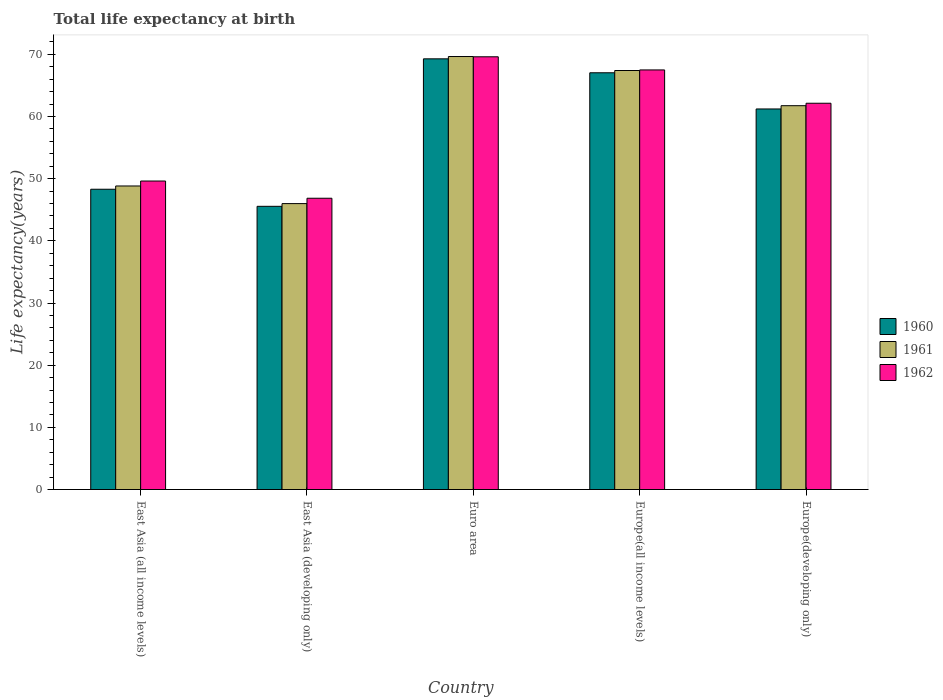How many different coloured bars are there?
Your response must be concise. 3. Are the number of bars on each tick of the X-axis equal?
Keep it short and to the point. Yes. How many bars are there on the 1st tick from the left?
Ensure brevity in your answer.  3. What is the label of the 4th group of bars from the left?
Make the answer very short. Europe(all income levels). What is the life expectancy at birth in in 1960 in Europe(all income levels)?
Your response must be concise. 67.03. Across all countries, what is the maximum life expectancy at birth in in 1960?
Offer a terse response. 69.27. Across all countries, what is the minimum life expectancy at birth in in 1961?
Offer a terse response. 45.99. In which country was the life expectancy at birth in in 1962 minimum?
Your response must be concise. East Asia (developing only). What is the total life expectancy at birth in in 1960 in the graph?
Your response must be concise. 291.36. What is the difference between the life expectancy at birth in in 1961 in East Asia (all income levels) and that in East Asia (developing only)?
Your response must be concise. 2.84. What is the difference between the life expectancy at birth in in 1960 in East Asia (developing only) and the life expectancy at birth in in 1962 in East Asia (all income levels)?
Your response must be concise. -4.07. What is the average life expectancy at birth in in 1962 per country?
Keep it short and to the point. 59.14. What is the difference between the life expectancy at birth in of/in 1962 and life expectancy at birth in of/in 1960 in East Asia (all income levels)?
Make the answer very short. 1.32. In how many countries, is the life expectancy at birth in in 1961 greater than 22 years?
Your answer should be very brief. 5. What is the ratio of the life expectancy at birth in in 1962 in Euro area to that in Europe(developing only)?
Keep it short and to the point. 1.12. Is the difference between the life expectancy at birth in in 1962 in Euro area and Europe(developing only) greater than the difference between the life expectancy at birth in in 1960 in Euro area and Europe(developing only)?
Offer a very short reply. No. What is the difference between the highest and the second highest life expectancy at birth in in 1962?
Give a very brief answer. -2.11. What is the difference between the highest and the lowest life expectancy at birth in in 1960?
Keep it short and to the point. 23.72. What does the 3rd bar from the right in East Asia (all income levels) represents?
Make the answer very short. 1960. Is it the case that in every country, the sum of the life expectancy at birth in in 1960 and life expectancy at birth in in 1962 is greater than the life expectancy at birth in in 1961?
Your answer should be compact. Yes. How many bars are there?
Provide a short and direct response. 15. Are all the bars in the graph horizontal?
Ensure brevity in your answer.  No. Does the graph contain any zero values?
Offer a terse response. No. How many legend labels are there?
Your response must be concise. 3. What is the title of the graph?
Keep it short and to the point. Total life expectancy at birth. What is the label or title of the Y-axis?
Provide a succinct answer. Life expectancy(years). What is the Life expectancy(years) in 1960 in East Asia (all income levels)?
Your answer should be compact. 48.3. What is the Life expectancy(years) of 1961 in East Asia (all income levels)?
Your answer should be very brief. 48.82. What is the Life expectancy(years) in 1962 in East Asia (all income levels)?
Give a very brief answer. 49.62. What is the Life expectancy(years) in 1960 in East Asia (developing only)?
Your response must be concise. 45.55. What is the Life expectancy(years) of 1961 in East Asia (developing only)?
Ensure brevity in your answer.  45.99. What is the Life expectancy(years) of 1962 in East Asia (developing only)?
Offer a terse response. 46.85. What is the Life expectancy(years) in 1960 in Euro area?
Your response must be concise. 69.27. What is the Life expectancy(years) in 1961 in Euro area?
Offer a very short reply. 69.64. What is the Life expectancy(years) in 1962 in Euro area?
Your answer should be very brief. 69.6. What is the Life expectancy(years) in 1960 in Europe(all income levels)?
Your answer should be compact. 67.03. What is the Life expectancy(years) of 1961 in Europe(all income levels)?
Your answer should be compact. 67.39. What is the Life expectancy(years) of 1962 in Europe(all income levels)?
Keep it short and to the point. 67.49. What is the Life expectancy(years) of 1960 in Europe(developing only)?
Provide a short and direct response. 61.21. What is the Life expectancy(years) of 1961 in Europe(developing only)?
Your answer should be very brief. 61.74. What is the Life expectancy(years) of 1962 in Europe(developing only)?
Your answer should be very brief. 62.13. Across all countries, what is the maximum Life expectancy(years) of 1960?
Provide a succinct answer. 69.27. Across all countries, what is the maximum Life expectancy(years) in 1961?
Offer a terse response. 69.64. Across all countries, what is the maximum Life expectancy(years) of 1962?
Make the answer very short. 69.6. Across all countries, what is the minimum Life expectancy(years) of 1960?
Offer a terse response. 45.55. Across all countries, what is the minimum Life expectancy(years) in 1961?
Make the answer very short. 45.99. Across all countries, what is the minimum Life expectancy(years) of 1962?
Offer a very short reply. 46.85. What is the total Life expectancy(years) of 1960 in the graph?
Make the answer very short. 291.36. What is the total Life expectancy(years) of 1961 in the graph?
Offer a terse response. 293.59. What is the total Life expectancy(years) in 1962 in the graph?
Provide a short and direct response. 295.69. What is the difference between the Life expectancy(years) in 1960 in East Asia (all income levels) and that in East Asia (developing only)?
Offer a very short reply. 2.75. What is the difference between the Life expectancy(years) of 1961 in East Asia (all income levels) and that in East Asia (developing only)?
Provide a succinct answer. 2.84. What is the difference between the Life expectancy(years) of 1962 in East Asia (all income levels) and that in East Asia (developing only)?
Make the answer very short. 2.77. What is the difference between the Life expectancy(years) in 1960 in East Asia (all income levels) and that in Euro area?
Keep it short and to the point. -20.98. What is the difference between the Life expectancy(years) of 1961 in East Asia (all income levels) and that in Euro area?
Keep it short and to the point. -20.82. What is the difference between the Life expectancy(years) in 1962 in East Asia (all income levels) and that in Euro area?
Provide a succinct answer. -19.98. What is the difference between the Life expectancy(years) in 1960 in East Asia (all income levels) and that in Europe(all income levels)?
Give a very brief answer. -18.73. What is the difference between the Life expectancy(years) of 1961 in East Asia (all income levels) and that in Europe(all income levels)?
Provide a succinct answer. -18.57. What is the difference between the Life expectancy(years) in 1962 in East Asia (all income levels) and that in Europe(all income levels)?
Your answer should be very brief. -17.87. What is the difference between the Life expectancy(years) in 1960 in East Asia (all income levels) and that in Europe(developing only)?
Ensure brevity in your answer.  -12.91. What is the difference between the Life expectancy(years) in 1961 in East Asia (all income levels) and that in Europe(developing only)?
Offer a terse response. -12.91. What is the difference between the Life expectancy(years) in 1962 in East Asia (all income levels) and that in Europe(developing only)?
Your response must be concise. -12.51. What is the difference between the Life expectancy(years) of 1960 in East Asia (developing only) and that in Euro area?
Provide a short and direct response. -23.72. What is the difference between the Life expectancy(years) of 1961 in East Asia (developing only) and that in Euro area?
Ensure brevity in your answer.  -23.66. What is the difference between the Life expectancy(years) of 1962 in East Asia (developing only) and that in Euro area?
Make the answer very short. -22.75. What is the difference between the Life expectancy(years) of 1960 in East Asia (developing only) and that in Europe(all income levels)?
Make the answer very short. -21.48. What is the difference between the Life expectancy(years) of 1961 in East Asia (developing only) and that in Europe(all income levels)?
Offer a terse response. -21.41. What is the difference between the Life expectancy(years) of 1962 in East Asia (developing only) and that in Europe(all income levels)?
Your response must be concise. -20.64. What is the difference between the Life expectancy(years) of 1960 in East Asia (developing only) and that in Europe(developing only)?
Your answer should be very brief. -15.66. What is the difference between the Life expectancy(years) of 1961 in East Asia (developing only) and that in Europe(developing only)?
Your answer should be compact. -15.75. What is the difference between the Life expectancy(years) of 1962 in East Asia (developing only) and that in Europe(developing only)?
Provide a short and direct response. -15.28. What is the difference between the Life expectancy(years) in 1960 in Euro area and that in Europe(all income levels)?
Provide a short and direct response. 2.24. What is the difference between the Life expectancy(years) in 1961 in Euro area and that in Europe(all income levels)?
Offer a terse response. 2.25. What is the difference between the Life expectancy(years) in 1962 in Euro area and that in Europe(all income levels)?
Your answer should be compact. 2.11. What is the difference between the Life expectancy(years) of 1960 in Euro area and that in Europe(developing only)?
Provide a succinct answer. 8.06. What is the difference between the Life expectancy(years) of 1961 in Euro area and that in Europe(developing only)?
Provide a succinct answer. 7.91. What is the difference between the Life expectancy(years) in 1962 in Euro area and that in Europe(developing only)?
Offer a very short reply. 7.47. What is the difference between the Life expectancy(years) of 1960 in Europe(all income levels) and that in Europe(developing only)?
Offer a very short reply. 5.82. What is the difference between the Life expectancy(years) in 1961 in Europe(all income levels) and that in Europe(developing only)?
Offer a very short reply. 5.66. What is the difference between the Life expectancy(years) in 1962 in Europe(all income levels) and that in Europe(developing only)?
Your answer should be compact. 5.36. What is the difference between the Life expectancy(years) in 1960 in East Asia (all income levels) and the Life expectancy(years) in 1961 in East Asia (developing only)?
Your answer should be very brief. 2.31. What is the difference between the Life expectancy(years) in 1960 in East Asia (all income levels) and the Life expectancy(years) in 1962 in East Asia (developing only)?
Your answer should be compact. 1.45. What is the difference between the Life expectancy(years) in 1961 in East Asia (all income levels) and the Life expectancy(years) in 1962 in East Asia (developing only)?
Your response must be concise. 1.97. What is the difference between the Life expectancy(years) of 1960 in East Asia (all income levels) and the Life expectancy(years) of 1961 in Euro area?
Make the answer very short. -21.35. What is the difference between the Life expectancy(years) in 1960 in East Asia (all income levels) and the Life expectancy(years) in 1962 in Euro area?
Ensure brevity in your answer.  -21.3. What is the difference between the Life expectancy(years) in 1961 in East Asia (all income levels) and the Life expectancy(years) in 1962 in Euro area?
Offer a terse response. -20.78. What is the difference between the Life expectancy(years) of 1960 in East Asia (all income levels) and the Life expectancy(years) of 1961 in Europe(all income levels)?
Provide a short and direct response. -19.1. What is the difference between the Life expectancy(years) in 1960 in East Asia (all income levels) and the Life expectancy(years) in 1962 in Europe(all income levels)?
Give a very brief answer. -19.19. What is the difference between the Life expectancy(years) in 1961 in East Asia (all income levels) and the Life expectancy(years) in 1962 in Europe(all income levels)?
Give a very brief answer. -18.67. What is the difference between the Life expectancy(years) in 1960 in East Asia (all income levels) and the Life expectancy(years) in 1961 in Europe(developing only)?
Offer a very short reply. -13.44. What is the difference between the Life expectancy(years) in 1960 in East Asia (all income levels) and the Life expectancy(years) in 1962 in Europe(developing only)?
Ensure brevity in your answer.  -13.83. What is the difference between the Life expectancy(years) of 1961 in East Asia (all income levels) and the Life expectancy(years) of 1962 in Europe(developing only)?
Provide a succinct answer. -13.31. What is the difference between the Life expectancy(years) in 1960 in East Asia (developing only) and the Life expectancy(years) in 1961 in Euro area?
Keep it short and to the point. -24.09. What is the difference between the Life expectancy(years) in 1960 in East Asia (developing only) and the Life expectancy(years) in 1962 in Euro area?
Provide a succinct answer. -24.05. What is the difference between the Life expectancy(years) of 1961 in East Asia (developing only) and the Life expectancy(years) of 1962 in Euro area?
Make the answer very short. -23.62. What is the difference between the Life expectancy(years) in 1960 in East Asia (developing only) and the Life expectancy(years) in 1961 in Europe(all income levels)?
Provide a short and direct response. -21.85. What is the difference between the Life expectancy(years) of 1960 in East Asia (developing only) and the Life expectancy(years) of 1962 in Europe(all income levels)?
Ensure brevity in your answer.  -21.94. What is the difference between the Life expectancy(years) in 1961 in East Asia (developing only) and the Life expectancy(years) in 1962 in Europe(all income levels)?
Offer a very short reply. -21.5. What is the difference between the Life expectancy(years) in 1960 in East Asia (developing only) and the Life expectancy(years) in 1961 in Europe(developing only)?
Provide a succinct answer. -16.19. What is the difference between the Life expectancy(years) in 1960 in East Asia (developing only) and the Life expectancy(years) in 1962 in Europe(developing only)?
Make the answer very short. -16.58. What is the difference between the Life expectancy(years) in 1961 in East Asia (developing only) and the Life expectancy(years) in 1962 in Europe(developing only)?
Ensure brevity in your answer.  -16.14. What is the difference between the Life expectancy(years) in 1960 in Euro area and the Life expectancy(years) in 1961 in Europe(all income levels)?
Keep it short and to the point. 1.88. What is the difference between the Life expectancy(years) of 1960 in Euro area and the Life expectancy(years) of 1962 in Europe(all income levels)?
Your response must be concise. 1.78. What is the difference between the Life expectancy(years) in 1961 in Euro area and the Life expectancy(years) in 1962 in Europe(all income levels)?
Your answer should be compact. 2.15. What is the difference between the Life expectancy(years) in 1960 in Euro area and the Life expectancy(years) in 1961 in Europe(developing only)?
Your response must be concise. 7.54. What is the difference between the Life expectancy(years) in 1960 in Euro area and the Life expectancy(years) in 1962 in Europe(developing only)?
Offer a very short reply. 7.14. What is the difference between the Life expectancy(years) in 1961 in Euro area and the Life expectancy(years) in 1962 in Europe(developing only)?
Give a very brief answer. 7.51. What is the difference between the Life expectancy(years) of 1960 in Europe(all income levels) and the Life expectancy(years) of 1961 in Europe(developing only)?
Make the answer very short. 5.29. What is the difference between the Life expectancy(years) in 1960 in Europe(all income levels) and the Life expectancy(years) in 1962 in Europe(developing only)?
Give a very brief answer. 4.9. What is the difference between the Life expectancy(years) of 1961 in Europe(all income levels) and the Life expectancy(years) of 1962 in Europe(developing only)?
Make the answer very short. 5.27. What is the average Life expectancy(years) of 1960 per country?
Your response must be concise. 58.27. What is the average Life expectancy(years) of 1961 per country?
Make the answer very short. 58.72. What is the average Life expectancy(years) in 1962 per country?
Offer a terse response. 59.14. What is the difference between the Life expectancy(years) in 1960 and Life expectancy(years) in 1961 in East Asia (all income levels)?
Your answer should be very brief. -0.53. What is the difference between the Life expectancy(years) in 1960 and Life expectancy(years) in 1962 in East Asia (all income levels)?
Provide a succinct answer. -1.32. What is the difference between the Life expectancy(years) of 1961 and Life expectancy(years) of 1962 in East Asia (all income levels)?
Your answer should be compact. -0.8. What is the difference between the Life expectancy(years) in 1960 and Life expectancy(years) in 1961 in East Asia (developing only)?
Make the answer very short. -0.44. What is the difference between the Life expectancy(years) in 1960 and Life expectancy(years) in 1962 in East Asia (developing only)?
Your answer should be compact. -1.3. What is the difference between the Life expectancy(years) of 1961 and Life expectancy(years) of 1962 in East Asia (developing only)?
Your answer should be very brief. -0.86. What is the difference between the Life expectancy(years) in 1960 and Life expectancy(years) in 1961 in Euro area?
Provide a succinct answer. -0.37. What is the difference between the Life expectancy(years) of 1960 and Life expectancy(years) of 1962 in Euro area?
Keep it short and to the point. -0.33. What is the difference between the Life expectancy(years) in 1961 and Life expectancy(years) in 1962 in Euro area?
Your answer should be compact. 0.04. What is the difference between the Life expectancy(years) in 1960 and Life expectancy(years) in 1961 in Europe(all income levels)?
Your answer should be compact. -0.36. What is the difference between the Life expectancy(years) in 1960 and Life expectancy(years) in 1962 in Europe(all income levels)?
Provide a succinct answer. -0.46. What is the difference between the Life expectancy(years) of 1961 and Life expectancy(years) of 1962 in Europe(all income levels)?
Provide a short and direct response. -0.09. What is the difference between the Life expectancy(years) in 1960 and Life expectancy(years) in 1961 in Europe(developing only)?
Offer a terse response. -0.53. What is the difference between the Life expectancy(years) of 1960 and Life expectancy(years) of 1962 in Europe(developing only)?
Make the answer very short. -0.92. What is the difference between the Life expectancy(years) of 1961 and Life expectancy(years) of 1962 in Europe(developing only)?
Offer a terse response. -0.39. What is the ratio of the Life expectancy(years) of 1960 in East Asia (all income levels) to that in East Asia (developing only)?
Offer a terse response. 1.06. What is the ratio of the Life expectancy(years) of 1961 in East Asia (all income levels) to that in East Asia (developing only)?
Give a very brief answer. 1.06. What is the ratio of the Life expectancy(years) in 1962 in East Asia (all income levels) to that in East Asia (developing only)?
Keep it short and to the point. 1.06. What is the ratio of the Life expectancy(years) in 1960 in East Asia (all income levels) to that in Euro area?
Give a very brief answer. 0.7. What is the ratio of the Life expectancy(years) in 1961 in East Asia (all income levels) to that in Euro area?
Your response must be concise. 0.7. What is the ratio of the Life expectancy(years) in 1962 in East Asia (all income levels) to that in Euro area?
Ensure brevity in your answer.  0.71. What is the ratio of the Life expectancy(years) of 1960 in East Asia (all income levels) to that in Europe(all income levels)?
Keep it short and to the point. 0.72. What is the ratio of the Life expectancy(years) of 1961 in East Asia (all income levels) to that in Europe(all income levels)?
Ensure brevity in your answer.  0.72. What is the ratio of the Life expectancy(years) of 1962 in East Asia (all income levels) to that in Europe(all income levels)?
Keep it short and to the point. 0.74. What is the ratio of the Life expectancy(years) of 1960 in East Asia (all income levels) to that in Europe(developing only)?
Make the answer very short. 0.79. What is the ratio of the Life expectancy(years) of 1961 in East Asia (all income levels) to that in Europe(developing only)?
Ensure brevity in your answer.  0.79. What is the ratio of the Life expectancy(years) of 1962 in East Asia (all income levels) to that in Europe(developing only)?
Ensure brevity in your answer.  0.8. What is the ratio of the Life expectancy(years) in 1960 in East Asia (developing only) to that in Euro area?
Give a very brief answer. 0.66. What is the ratio of the Life expectancy(years) in 1961 in East Asia (developing only) to that in Euro area?
Provide a succinct answer. 0.66. What is the ratio of the Life expectancy(years) of 1962 in East Asia (developing only) to that in Euro area?
Make the answer very short. 0.67. What is the ratio of the Life expectancy(years) in 1960 in East Asia (developing only) to that in Europe(all income levels)?
Give a very brief answer. 0.68. What is the ratio of the Life expectancy(years) of 1961 in East Asia (developing only) to that in Europe(all income levels)?
Offer a very short reply. 0.68. What is the ratio of the Life expectancy(years) in 1962 in East Asia (developing only) to that in Europe(all income levels)?
Ensure brevity in your answer.  0.69. What is the ratio of the Life expectancy(years) of 1960 in East Asia (developing only) to that in Europe(developing only)?
Provide a short and direct response. 0.74. What is the ratio of the Life expectancy(years) in 1961 in East Asia (developing only) to that in Europe(developing only)?
Your answer should be very brief. 0.74. What is the ratio of the Life expectancy(years) in 1962 in East Asia (developing only) to that in Europe(developing only)?
Your answer should be compact. 0.75. What is the ratio of the Life expectancy(years) of 1960 in Euro area to that in Europe(all income levels)?
Your answer should be very brief. 1.03. What is the ratio of the Life expectancy(years) of 1961 in Euro area to that in Europe(all income levels)?
Provide a short and direct response. 1.03. What is the ratio of the Life expectancy(years) of 1962 in Euro area to that in Europe(all income levels)?
Give a very brief answer. 1.03. What is the ratio of the Life expectancy(years) in 1960 in Euro area to that in Europe(developing only)?
Offer a very short reply. 1.13. What is the ratio of the Life expectancy(years) in 1961 in Euro area to that in Europe(developing only)?
Offer a very short reply. 1.13. What is the ratio of the Life expectancy(years) of 1962 in Euro area to that in Europe(developing only)?
Your answer should be very brief. 1.12. What is the ratio of the Life expectancy(years) in 1960 in Europe(all income levels) to that in Europe(developing only)?
Your answer should be compact. 1.1. What is the ratio of the Life expectancy(years) of 1961 in Europe(all income levels) to that in Europe(developing only)?
Keep it short and to the point. 1.09. What is the ratio of the Life expectancy(years) in 1962 in Europe(all income levels) to that in Europe(developing only)?
Provide a succinct answer. 1.09. What is the difference between the highest and the second highest Life expectancy(years) in 1960?
Provide a succinct answer. 2.24. What is the difference between the highest and the second highest Life expectancy(years) in 1961?
Make the answer very short. 2.25. What is the difference between the highest and the second highest Life expectancy(years) of 1962?
Offer a very short reply. 2.11. What is the difference between the highest and the lowest Life expectancy(years) of 1960?
Keep it short and to the point. 23.72. What is the difference between the highest and the lowest Life expectancy(years) of 1961?
Keep it short and to the point. 23.66. What is the difference between the highest and the lowest Life expectancy(years) of 1962?
Give a very brief answer. 22.75. 